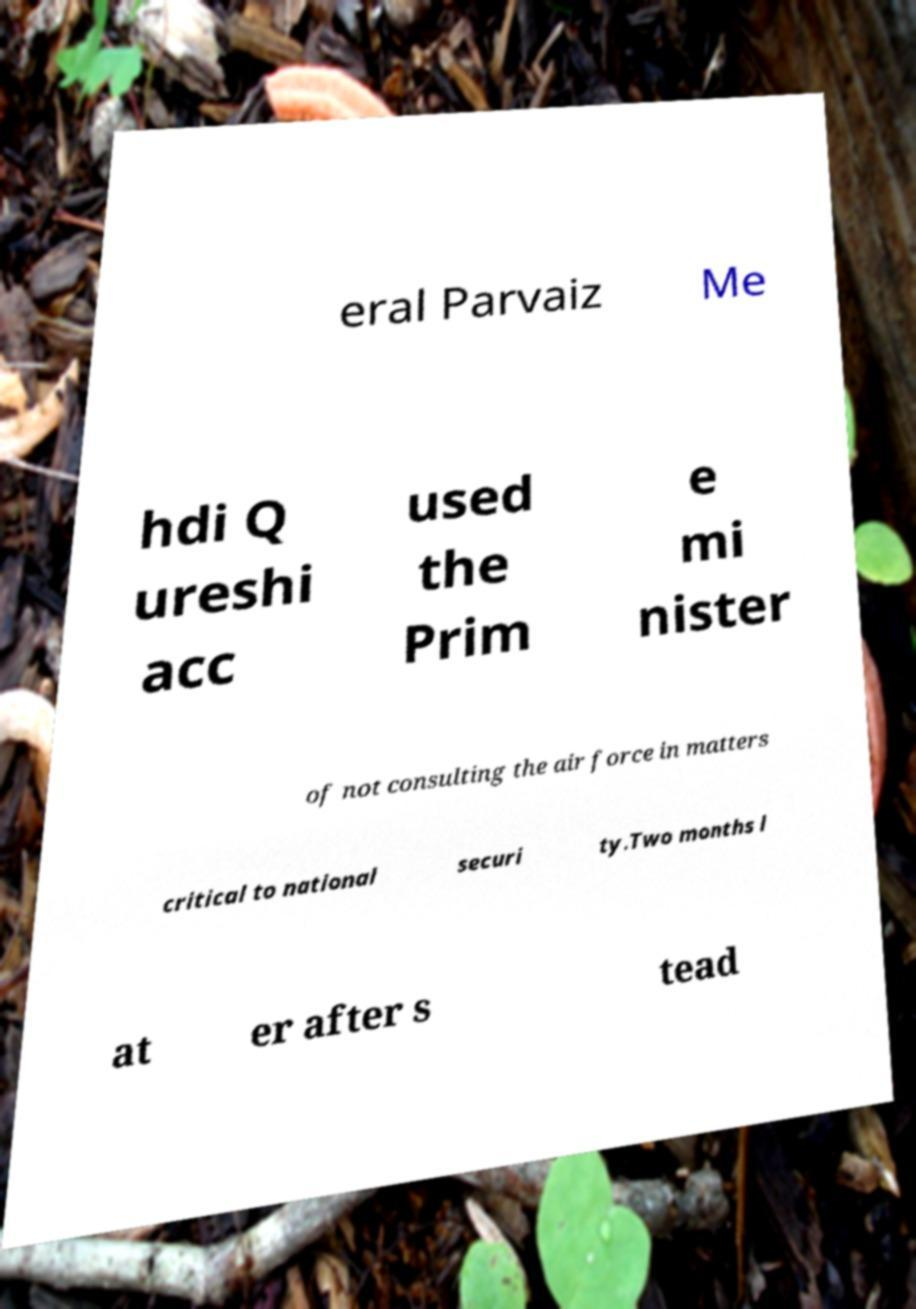Could you extract and type out the text from this image? eral Parvaiz Me hdi Q ureshi acc used the Prim e mi nister of not consulting the air force in matters critical to national securi ty.Two months l at er after s tead 